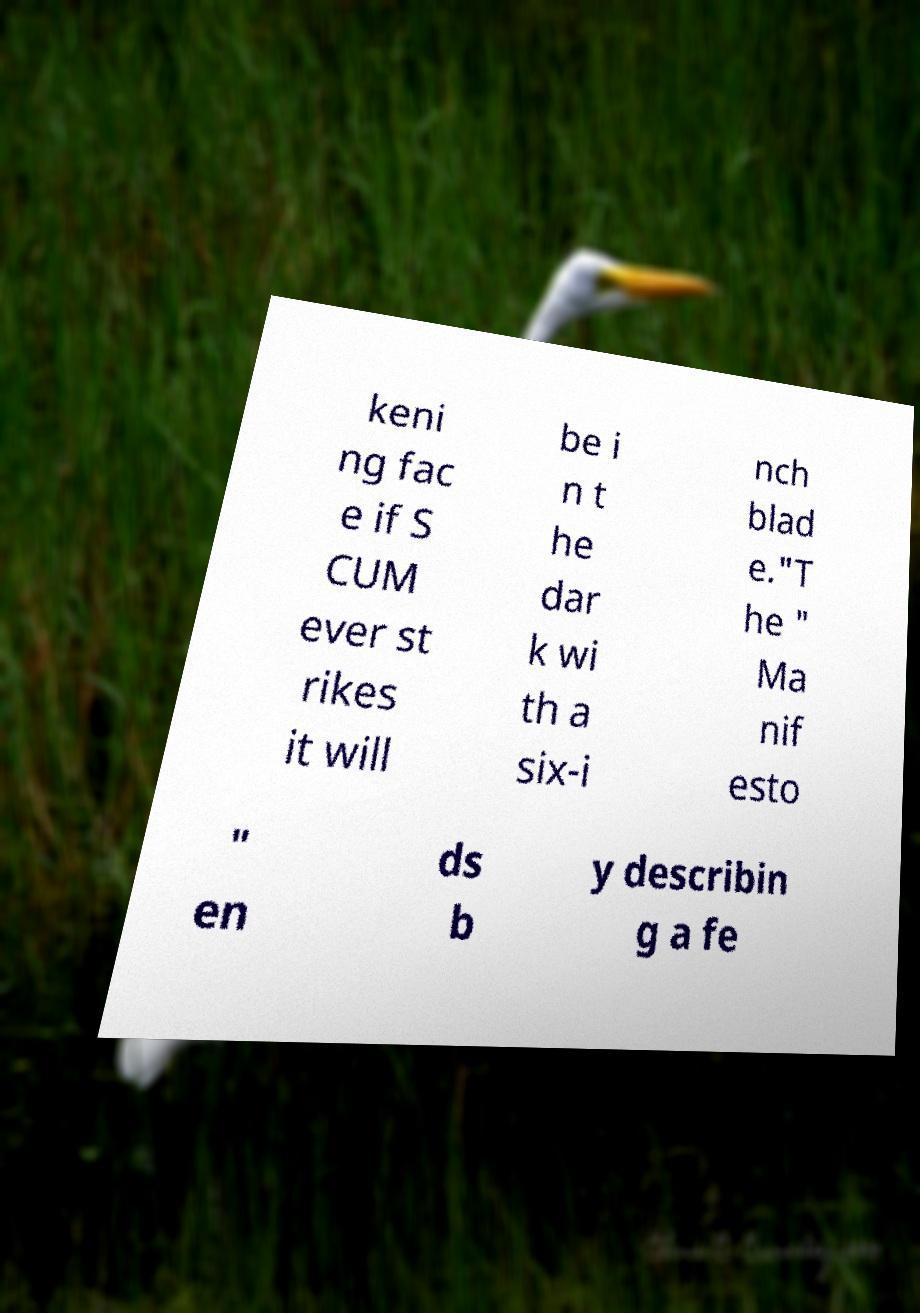Please identify and transcribe the text found in this image. keni ng fac e if S CUM ever st rikes it will be i n t he dar k wi th a six-i nch blad e."T he " Ma nif esto " en ds b y describin g a fe 